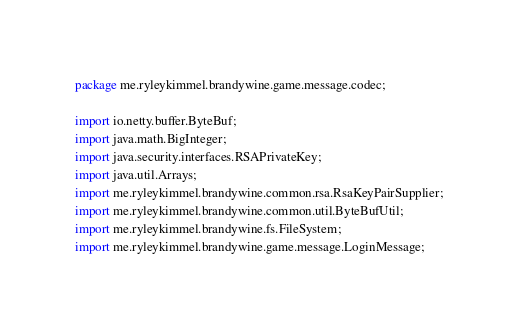<code> <loc_0><loc_0><loc_500><loc_500><_Java_>package me.ryleykimmel.brandywine.game.message.codec;

import io.netty.buffer.ByteBuf;
import java.math.BigInteger;
import java.security.interfaces.RSAPrivateKey;
import java.util.Arrays;
import me.ryleykimmel.brandywine.common.rsa.RsaKeyPairSupplier;
import me.ryleykimmel.brandywine.common.util.ByteBufUtil;
import me.ryleykimmel.brandywine.fs.FileSystem;
import me.ryleykimmel.brandywine.game.message.LoginMessage;</code> 